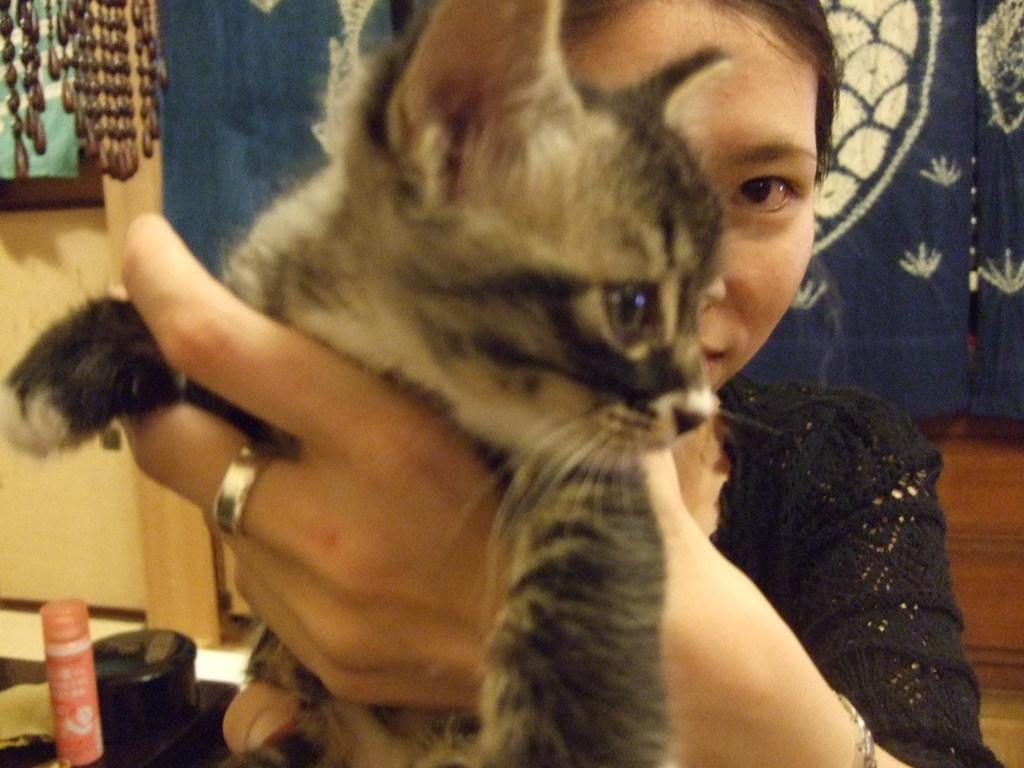Who is present in the image? There is a woman in the image. What is the woman wearing? The woman is wearing clothes and a finger ring. What is the woman holding in her hand? The woman is holding a cat in her hand. What can be seen in the background of the image? There are objects and curtains in the image. How would you describe the quality of the image? The image is slightly blurred. Where is the mailbox located in the image? There is no mailbox present in the image. What type of food is being served in the lunchroom in the image? There is no lunchroom present in the image. 